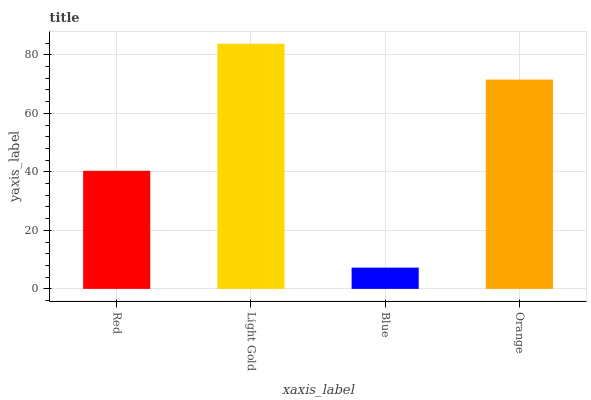Is Light Gold the minimum?
Answer yes or no. No. Is Blue the maximum?
Answer yes or no. No. Is Light Gold greater than Blue?
Answer yes or no. Yes. Is Blue less than Light Gold?
Answer yes or no. Yes. Is Blue greater than Light Gold?
Answer yes or no. No. Is Light Gold less than Blue?
Answer yes or no. No. Is Orange the high median?
Answer yes or no. Yes. Is Red the low median?
Answer yes or no. Yes. Is Blue the high median?
Answer yes or no. No. Is Orange the low median?
Answer yes or no. No. 